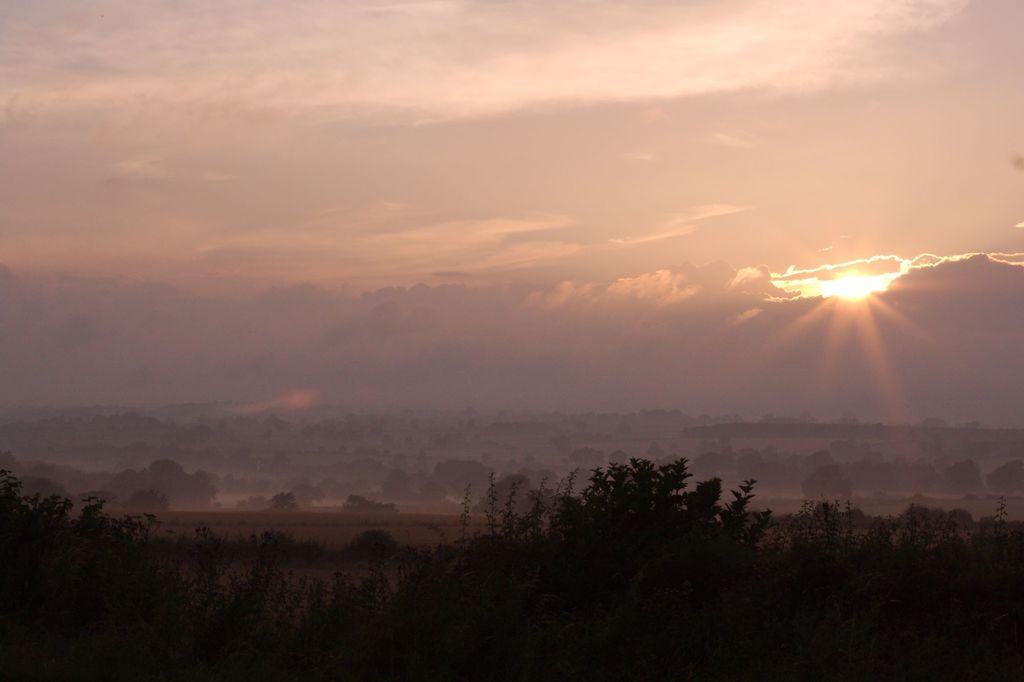Describe this image in one or two sentences. In this image we can see a group of trees. On the right side of the image we can see the sun in the sky. 